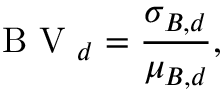<formula> <loc_0><loc_0><loc_500><loc_500>B V _ { d } = \frac { \sigma _ { B , d } } { \mu _ { B , d } } ,</formula> 